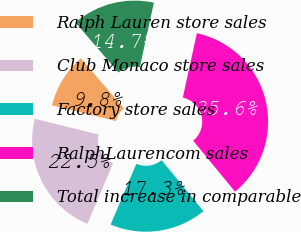<chart> <loc_0><loc_0><loc_500><loc_500><pie_chart><fcel>Ralph Lauren store sales<fcel>Club Monaco store sales<fcel>Factory store sales<fcel>RalphLaurencom sales<fcel>Total increase in comparable<nl><fcel>9.83%<fcel>22.48%<fcel>17.32%<fcel>35.63%<fcel>14.74%<nl></chart> 